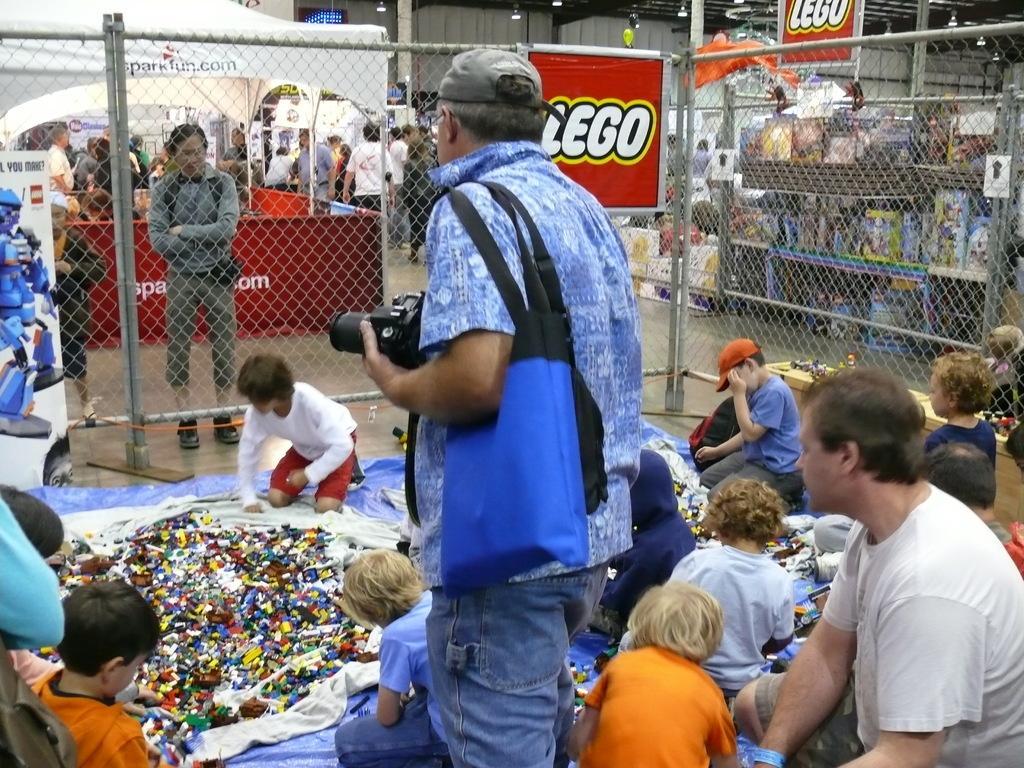Can you describe this image briefly? In this image we can see some persons, camera, bag and other objects. In the background of the image there is a fence, name boards, lights, persons, wall and other objects. 